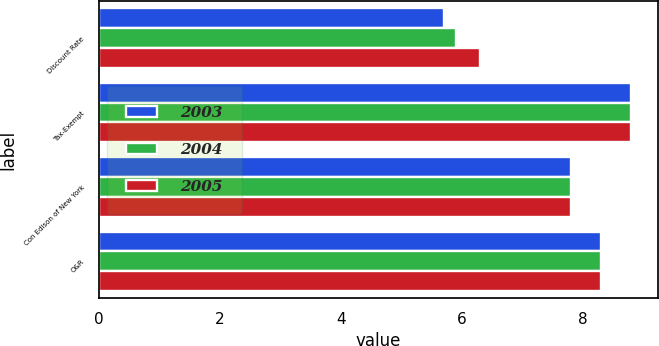Convert chart. <chart><loc_0><loc_0><loc_500><loc_500><stacked_bar_chart><ecel><fcel>Discount Rate<fcel>Tax-Exempt<fcel>Con Edison of New York<fcel>O&R<nl><fcel>2003<fcel>5.7<fcel>8.8<fcel>7.8<fcel>8.3<nl><fcel>2004<fcel>5.9<fcel>8.8<fcel>7.8<fcel>8.3<nl><fcel>2005<fcel>6.3<fcel>8.8<fcel>7.8<fcel>8.3<nl></chart> 